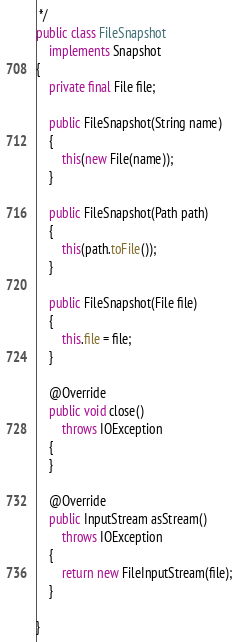Convert code to text. <code><loc_0><loc_0><loc_500><loc_500><_Java_> */
public class FileSnapshot
	implements Snapshot
{
	private final File file;

	public FileSnapshot(String name)
	{
		this(new File(name));
	}

	public FileSnapshot(Path path)
	{
		this(path.toFile());
	}

	public FileSnapshot(File file)
	{
		this.file = file;
	}

	@Override
	public void close()
		throws IOException
	{
	}

	@Override
	public InputStream asStream()
		throws IOException
	{
		return new FileInputStream(file);
	}

}
</code> 